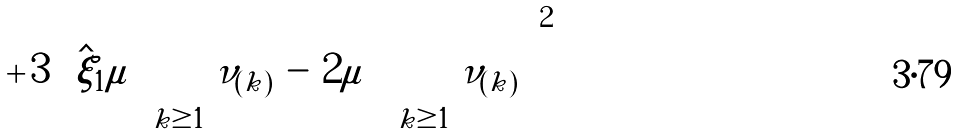<formula> <loc_0><loc_0><loc_500><loc_500>+ \, 3 \left ( { \hat { \xi } } _ { 1 } \mu \right ) \sum _ { k \geq 1 } \nu _ { ( k ) } \, - \, 2 \mu \, \left ( \sum _ { k \geq 1 } \nu _ { ( k ) } \right ) ^ { 2 }</formula> 